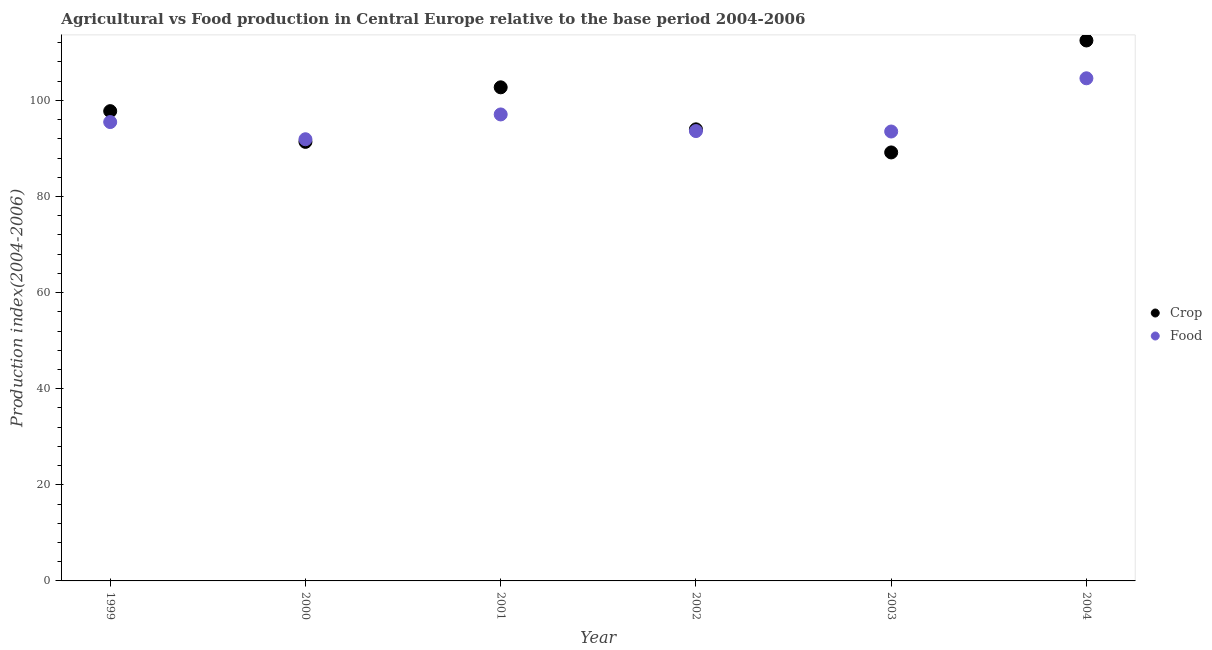How many different coloured dotlines are there?
Keep it short and to the point. 2. Is the number of dotlines equal to the number of legend labels?
Your response must be concise. Yes. What is the crop production index in 1999?
Your response must be concise. 97.76. Across all years, what is the maximum food production index?
Provide a short and direct response. 104.6. Across all years, what is the minimum food production index?
Give a very brief answer. 91.91. What is the total crop production index in the graph?
Offer a terse response. 587.45. What is the difference between the food production index in 1999 and that in 2000?
Ensure brevity in your answer.  3.58. What is the difference between the food production index in 2003 and the crop production index in 2000?
Your answer should be very brief. 2.15. What is the average food production index per year?
Your response must be concise. 96.03. In the year 2001, what is the difference between the crop production index and food production index?
Offer a very short reply. 5.64. What is the ratio of the crop production index in 1999 to that in 2003?
Keep it short and to the point. 1.1. What is the difference between the highest and the second highest food production index?
Your response must be concise. 7.52. What is the difference between the highest and the lowest food production index?
Your response must be concise. 12.68. In how many years, is the crop production index greater than the average crop production index taken over all years?
Offer a very short reply. 2. Is the sum of the food production index in 2000 and 2004 greater than the maximum crop production index across all years?
Keep it short and to the point. Yes. Is the crop production index strictly greater than the food production index over the years?
Make the answer very short. No. Is the crop production index strictly less than the food production index over the years?
Your answer should be compact. No. How many dotlines are there?
Offer a very short reply. 2. How many years are there in the graph?
Provide a short and direct response. 6. Does the graph contain any zero values?
Offer a very short reply. No. Does the graph contain grids?
Ensure brevity in your answer.  No. Where does the legend appear in the graph?
Offer a very short reply. Center right. How many legend labels are there?
Ensure brevity in your answer.  2. What is the title of the graph?
Give a very brief answer. Agricultural vs Food production in Central Europe relative to the base period 2004-2006. What is the label or title of the Y-axis?
Your answer should be very brief. Production index(2004-2006). What is the Production index(2004-2006) of Crop in 1999?
Make the answer very short. 97.76. What is the Production index(2004-2006) of Food in 1999?
Provide a short and direct response. 95.49. What is the Production index(2004-2006) of Crop in 2000?
Your response must be concise. 91.37. What is the Production index(2004-2006) in Food in 2000?
Make the answer very short. 91.91. What is the Production index(2004-2006) of Crop in 2001?
Keep it short and to the point. 102.72. What is the Production index(2004-2006) of Food in 2001?
Provide a short and direct response. 97.07. What is the Production index(2004-2006) in Crop in 2002?
Your answer should be very brief. 93.97. What is the Production index(2004-2006) of Food in 2002?
Your answer should be very brief. 93.61. What is the Production index(2004-2006) in Crop in 2003?
Give a very brief answer. 89.17. What is the Production index(2004-2006) of Food in 2003?
Your answer should be compact. 93.52. What is the Production index(2004-2006) in Crop in 2004?
Your answer should be compact. 112.47. What is the Production index(2004-2006) of Food in 2004?
Keep it short and to the point. 104.6. Across all years, what is the maximum Production index(2004-2006) of Crop?
Ensure brevity in your answer.  112.47. Across all years, what is the maximum Production index(2004-2006) in Food?
Make the answer very short. 104.6. Across all years, what is the minimum Production index(2004-2006) in Crop?
Ensure brevity in your answer.  89.17. Across all years, what is the minimum Production index(2004-2006) of Food?
Your response must be concise. 91.91. What is the total Production index(2004-2006) in Crop in the graph?
Your answer should be very brief. 587.45. What is the total Production index(2004-2006) of Food in the graph?
Provide a short and direct response. 576.21. What is the difference between the Production index(2004-2006) in Crop in 1999 and that in 2000?
Give a very brief answer. 6.39. What is the difference between the Production index(2004-2006) in Food in 1999 and that in 2000?
Provide a succinct answer. 3.58. What is the difference between the Production index(2004-2006) of Crop in 1999 and that in 2001?
Your response must be concise. -4.96. What is the difference between the Production index(2004-2006) of Food in 1999 and that in 2001?
Give a very brief answer. -1.59. What is the difference between the Production index(2004-2006) in Crop in 1999 and that in 2002?
Your response must be concise. 3.79. What is the difference between the Production index(2004-2006) in Food in 1999 and that in 2002?
Provide a succinct answer. 1.87. What is the difference between the Production index(2004-2006) of Crop in 1999 and that in 2003?
Offer a very short reply. 8.59. What is the difference between the Production index(2004-2006) of Food in 1999 and that in 2003?
Offer a very short reply. 1.97. What is the difference between the Production index(2004-2006) of Crop in 1999 and that in 2004?
Offer a terse response. -14.7. What is the difference between the Production index(2004-2006) in Food in 1999 and that in 2004?
Keep it short and to the point. -9.11. What is the difference between the Production index(2004-2006) of Crop in 2000 and that in 2001?
Your response must be concise. -11.35. What is the difference between the Production index(2004-2006) in Food in 2000 and that in 2001?
Keep it short and to the point. -5.16. What is the difference between the Production index(2004-2006) of Crop in 2000 and that in 2002?
Give a very brief answer. -2.61. What is the difference between the Production index(2004-2006) in Food in 2000 and that in 2002?
Your answer should be very brief. -1.7. What is the difference between the Production index(2004-2006) in Crop in 2000 and that in 2003?
Provide a short and direct response. 2.2. What is the difference between the Production index(2004-2006) of Food in 2000 and that in 2003?
Keep it short and to the point. -1.61. What is the difference between the Production index(2004-2006) in Crop in 2000 and that in 2004?
Your response must be concise. -21.1. What is the difference between the Production index(2004-2006) in Food in 2000 and that in 2004?
Your response must be concise. -12.68. What is the difference between the Production index(2004-2006) in Crop in 2001 and that in 2002?
Give a very brief answer. 8.74. What is the difference between the Production index(2004-2006) in Food in 2001 and that in 2002?
Provide a short and direct response. 3.46. What is the difference between the Production index(2004-2006) in Crop in 2001 and that in 2003?
Your response must be concise. 13.55. What is the difference between the Production index(2004-2006) in Food in 2001 and that in 2003?
Offer a very short reply. 3.55. What is the difference between the Production index(2004-2006) of Crop in 2001 and that in 2004?
Offer a very short reply. -9.75. What is the difference between the Production index(2004-2006) in Food in 2001 and that in 2004?
Your answer should be very brief. -7.52. What is the difference between the Production index(2004-2006) in Crop in 2002 and that in 2003?
Offer a terse response. 4.81. What is the difference between the Production index(2004-2006) of Food in 2002 and that in 2003?
Ensure brevity in your answer.  0.09. What is the difference between the Production index(2004-2006) in Crop in 2002 and that in 2004?
Ensure brevity in your answer.  -18.49. What is the difference between the Production index(2004-2006) in Food in 2002 and that in 2004?
Offer a very short reply. -10.98. What is the difference between the Production index(2004-2006) of Crop in 2003 and that in 2004?
Give a very brief answer. -23.3. What is the difference between the Production index(2004-2006) of Food in 2003 and that in 2004?
Give a very brief answer. -11.07. What is the difference between the Production index(2004-2006) in Crop in 1999 and the Production index(2004-2006) in Food in 2000?
Make the answer very short. 5.85. What is the difference between the Production index(2004-2006) in Crop in 1999 and the Production index(2004-2006) in Food in 2001?
Your answer should be compact. 0.69. What is the difference between the Production index(2004-2006) of Crop in 1999 and the Production index(2004-2006) of Food in 2002?
Provide a short and direct response. 4.15. What is the difference between the Production index(2004-2006) of Crop in 1999 and the Production index(2004-2006) of Food in 2003?
Keep it short and to the point. 4.24. What is the difference between the Production index(2004-2006) in Crop in 1999 and the Production index(2004-2006) in Food in 2004?
Provide a short and direct response. -6.83. What is the difference between the Production index(2004-2006) in Crop in 2000 and the Production index(2004-2006) in Food in 2001?
Provide a short and direct response. -5.71. What is the difference between the Production index(2004-2006) of Crop in 2000 and the Production index(2004-2006) of Food in 2002?
Your answer should be very brief. -2.25. What is the difference between the Production index(2004-2006) of Crop in 2000 and the Production index(2004-2006) of Food in 2003?
Your answer should be very brief. -2.15. What is the difference between the Production index(2004-2006) of Crop in 2000 and the Production index(2004-2006) of Food in 2004?
Offer a terse response. -13.23. What is the difference between the Production index(2004-2006) of Crop in 2001 and the Production index(2004-2006) of Food in 2002?
Give a very brief answer. 9.1. What is the difference between the Production index(2004-2006) in Crop in 2001 and the Production index(2004-2006) in Food in 2003?
Your response must be concise. 9.2. What is the difference between the Production index(2004-2006) of Crop in 2001 and the Production index(2004-2006) of Food in 2004?
Offer a terse response. -1.88. What is the difference between the Production index(2004-2006) of Crop in 2002 and the Production index(2004-2006) of Food in 2003?
Your answer should be very brief. 0.45. What is the difference between the Production index(2004-2006) of Crop in 2002 and the Production index(2004-2006) of Food in 2004?
Your answer should be compact. -10.62. What is the difference between the Production index(2004-2006) in Crop in 2003 and the Production index(2004-2006) in Food in 2004?
Your answer should be compact. -15.43. What is the average Production index(2004-2006) in Crop per year?
Provide a succinct answer. 97.91. What is the average Production index(2004-2006) in Food per year?
Make the answer very short. 96.03. In the year 1999, what is the difference between the Production index(2004-2006) of Crop and Production index(2004-2006) of Food?
Your answer should be very brief. 2.27. In the year 2000, what is the difference between the Production index(2004-2006) in Crop and Production index(2004-2006) in Food?
Provide a short and direct response. -0.54. In the year 2001, what is the difference between the Production index(2004-2006) of Crop and Production index(2004-2006) of Food?
Your answer should be compact. 5.64. In the year 2002, what is the difference between the Production index(2004-2006) of Crop and Production index(2004-2006) of Food?
Make the answer very short. 0.36. In the year 2003, what is the difference between the Production index(2004-2006) in Crop and Production index(2004-2006) in Food?
Your answer should be very brief. -4.35. In the year 2004, what is the difference between the Production index(2004-2006) in Crop and Production index(2004-2006) in Food?
Give a very brief answer. 7.87. What is the ratio of the Production index(2004-2006) in Crop in 1999 to that in 2000?
Keep it short and to the point. 1.07. What is the ratio of the Production index(2004-2006) of Food in 1999 to that in 2000?
Your response must be concise. 1.04. What is the ratio of the Production index(2004-2006) of Crop in 1999 to that in 2001?
Provide a succinct answer. 0.95. What is the ratio of the Production index(2004-2006) in Food in 1999 to that in 2001?
Offer a very short reply. 0.98. What is the ratio of the Production index(2004-2006) of Crop in 1999 to that in 2002?
Provide a short and direct response. 1.04. What is the ratio of the Production index(2004-2006) of Crop in 1999 to that in 2003?
Offer a terse response. 1.1. What is the ratio of the Production index(2004-2006) in Food in 1999 to that in 2003?
Give a very brief answer. 1.02. What is the ratio of the Production index(2004-2006) in Crop in 1999 to that in 2004?
Provide a short and direct response. 0.87. What is the ratio of the Production index(2004-2006) in Food in 1999 to that in 2004?
Make the answer very short. 0.91. What is the ratio of the Production index(2004-2006) in Crop in 2000 to that in 2001?
Give a very brief answer. 0.89. What is the ratio of the Production index(2004-2006) in Food in 2000 to that in 2001?
Provide a short and direct response. 0.95. What is the ratio of the Production index(2004-2006) of Crop in 2000 to that in 2002?
Keep it short and to the point. 0.97. What is the ratio of the Production index(2004-2006) in Food in 2000 to that in 2002?
Provide a short and direct response. 0.98. What is the ratio of the Production index(2004-2006) in Crop in 2000 to that in 2003?
Your answer should be very brief. 1.02. What is the ratio of the Production index(2004-2006) of Food in 2000 to that in 2003?
Provide a succinct answer. 0.98. What is the ratio of the Production index(2004-2006) in Crop in 2000 to that in 2004?
Your answer should be compact. 0.81. What is the ratio of the Production index(2004-2006) of Food in 2000 to that in 2004?
Give a very brief answer. 0.88. What is the ratio of the Production index(2004-2006) in Crop in 2001 to that in 2002?
Give a very brief answer. 1.09. What is the ratio of the Production index(2004-2006) of Crop in 2001 to that in 2003?
Provide a succinct answer. 1.15. What is the ratio of the Production index(2004-2006) in Food in 2001 to that in 2003?
Your response must be concise. 1.04. What is the ratio of the Production index(2004-2006) of Crop in 2001 to that in 2004?
Give a very brief answer. 0.91. What is the ratio of the Production index(2004-2006) of Food in 2001 to that in 2004?
Ensure brevity in your answer.  0.93. What is the ratio of the Production index(2004-2006) of Crop in 2002 to that in 2003?
Ensure brevity in your answer.  1.05. What is the ratio of the Production index(2004-2006) of Crop in 2002 to that in 2004?
Give a very brief answer. 0.84. What is the ratio of the Production index(2004-2006) in Food in 2002 to that in 2004?
Offer a very short reply. 0.9. What is the ratio of the Production index(2004-2006) of Crop in 2003 to that in 2004?
Ensure brevity in your answer.  0.79. What is the ratio of the Production index(2004-2006) in Food in 2003 to that in 2004?
Give a very brief answer. 0.89. What is the difference between the highest and the second highest Production index(2004-2006) of Crop?
Make the answer very short. 9.75. What is the difference between the highest and the second highest Production index(2004-2006) of Food?
Your response must be concise. 7.52. What is the difference between the highest and the lowest Production index(2004-2006) in Crop?
Offer a very short reply. 23.3. What is the difference between the highest and the lowest Production index(2004-2006) in Food?
Keep it short and to the point. 12.68. 